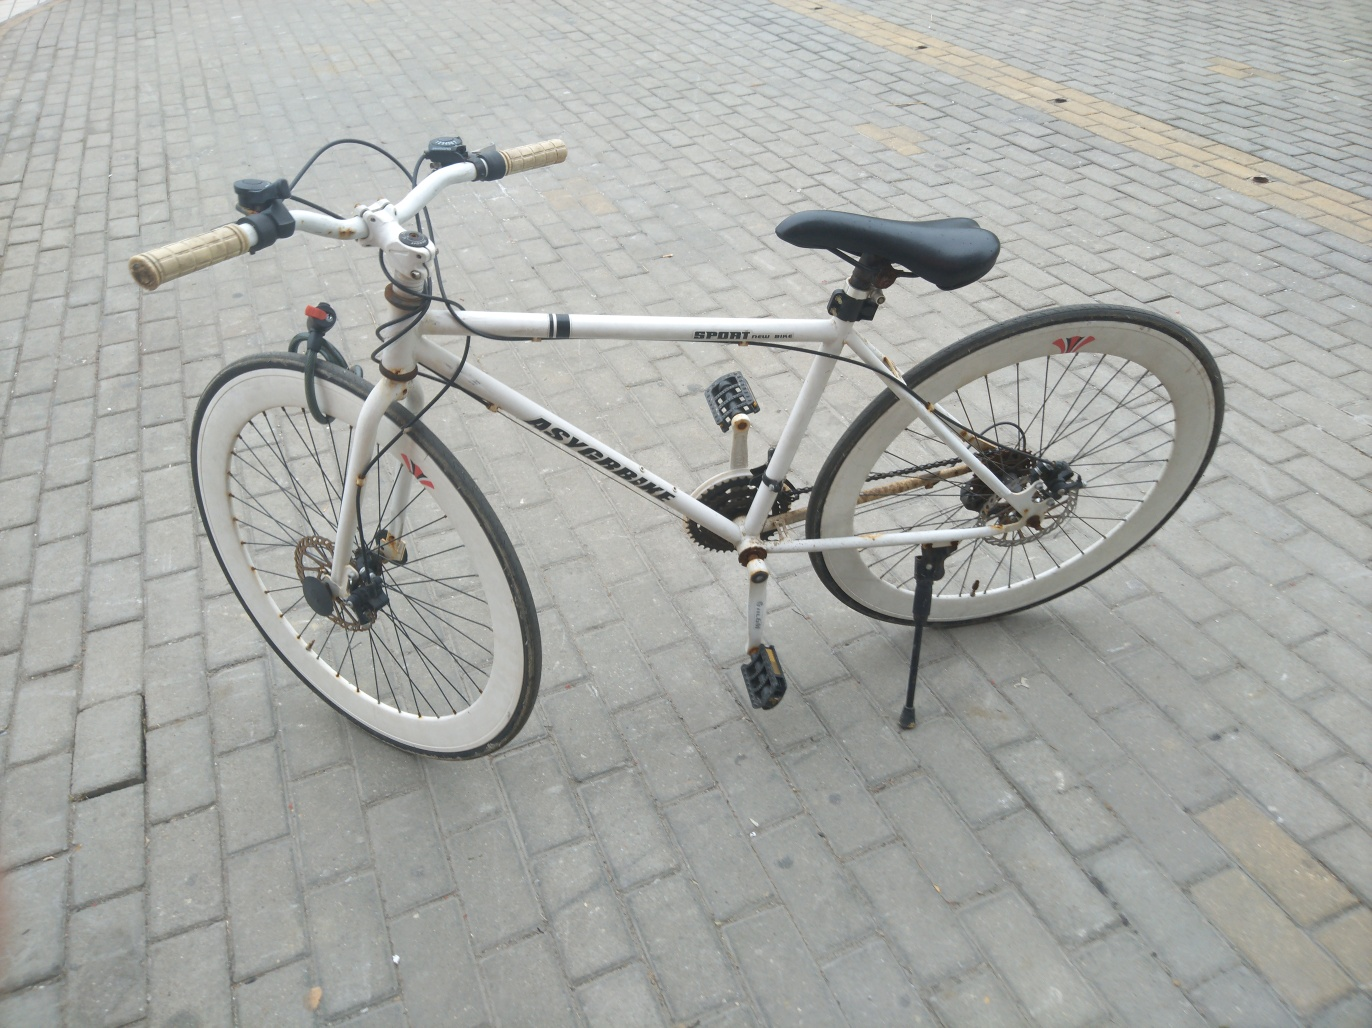What suggestions would you give for the maintenance of the bicycle? To ensure optimal performance and longevity, it would be advisable to clean the bicycle regularly to remove dirt and grime, particularly from the chain and gear cogs. Checking the tire pressure and brake function, and lubricating moving parts, would also be beneficial. Keeping the bicycle clean not only maintains its appearance but also prevents wear and tear. 